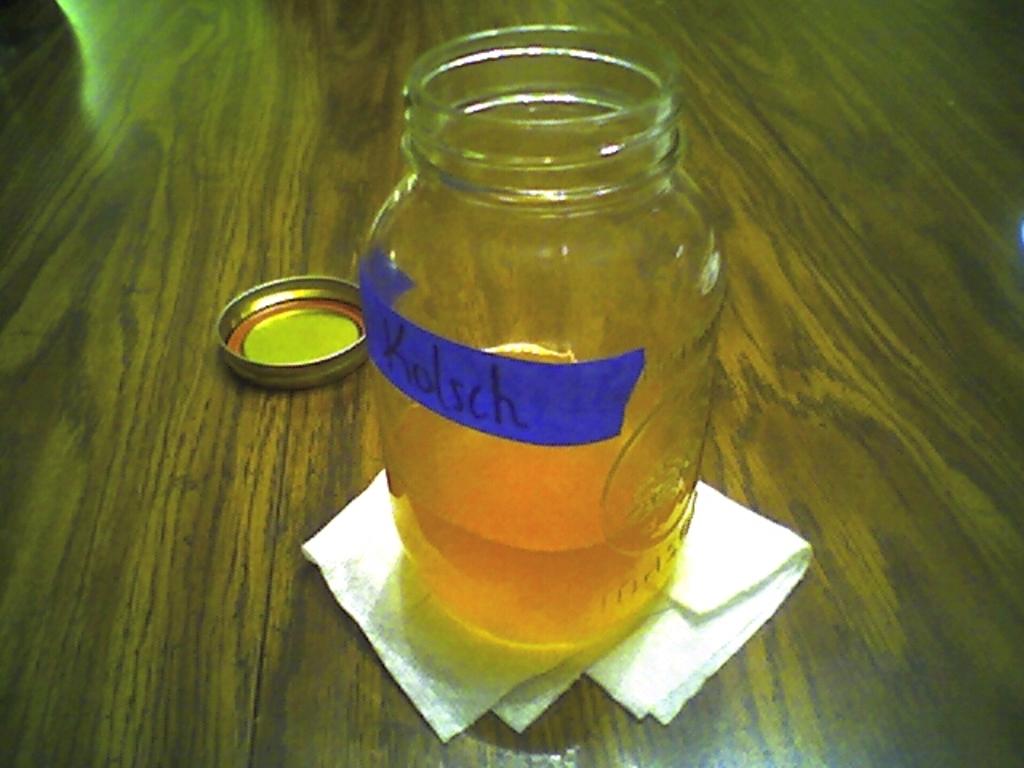Who is listed on the jar?
Provide a succinct answer. Kolsch. 